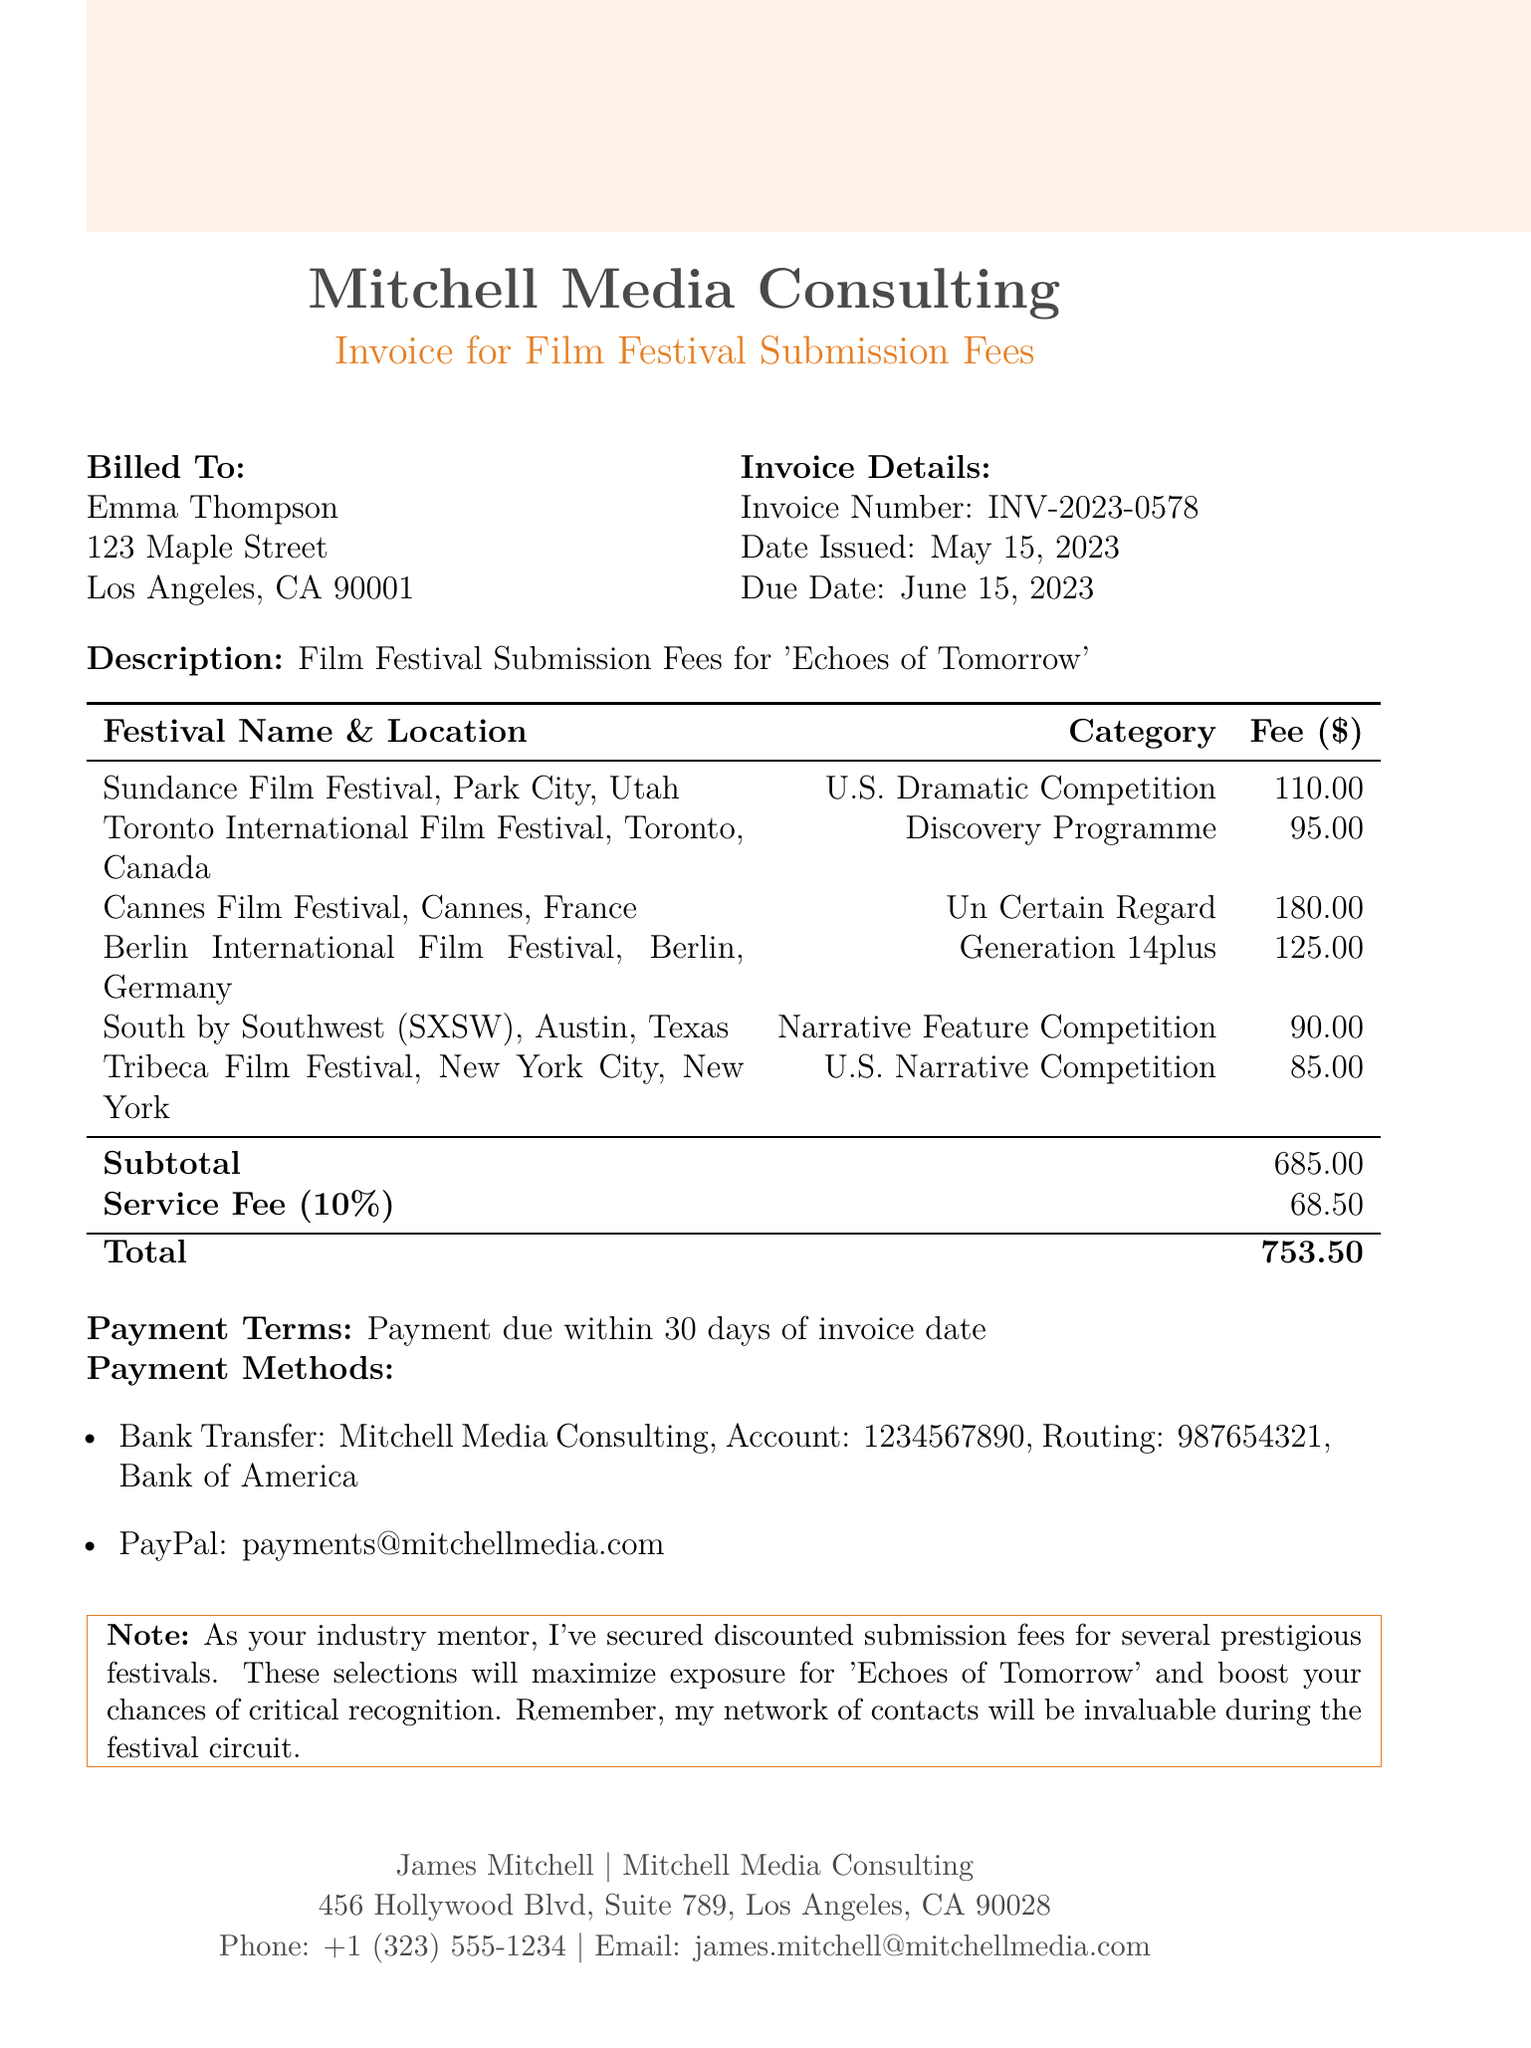What is the invoice number? The invoice number is provided in the document as a unique identifier for the transaction.
Answer: INV-2023-0578 What is the due date for the payment? The due date indicates when the billed amount must be paid, which is listed in the document.
Answer: June 15, 2023 Who is the invoice billed to? The document specifies an individual or entity to whom the invoice is issued.
Answer: Emma Thompson How much is the total amount due? The total amount is the final amount that is owed, calculated by including the subtotal and service fee.
Answer: 753.50 What is the subtotal for the submission fees? The subtotal represents the total of all individual submission fees before additional costs like service fees are added.
Answer: 685 Which festival has the highest submission fee? This information compares all listed festivals to determine which fees are highest.
Answer: Cannes Film Festival What payment method is provided for PayPal? The document includes alternative payment methods, specifying details for PayPal transactions.
Answer: payments@mitchellmedia.com What is the service fee percentage? The service fee is represented as a percentage of the subtotal in the document.
Answer: 10% In which category is the Sundance Film Festival submitted? Each festival has its respective category listed, explaining its competitive context.
Answer: U.S. Dramatic Competition 